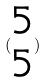Convert formula to latex. <formula><loc_0><loc_0><loc_500><loc_500>( \begin{matrix} 5 \\ 5 \end{matrix} )</formula> 